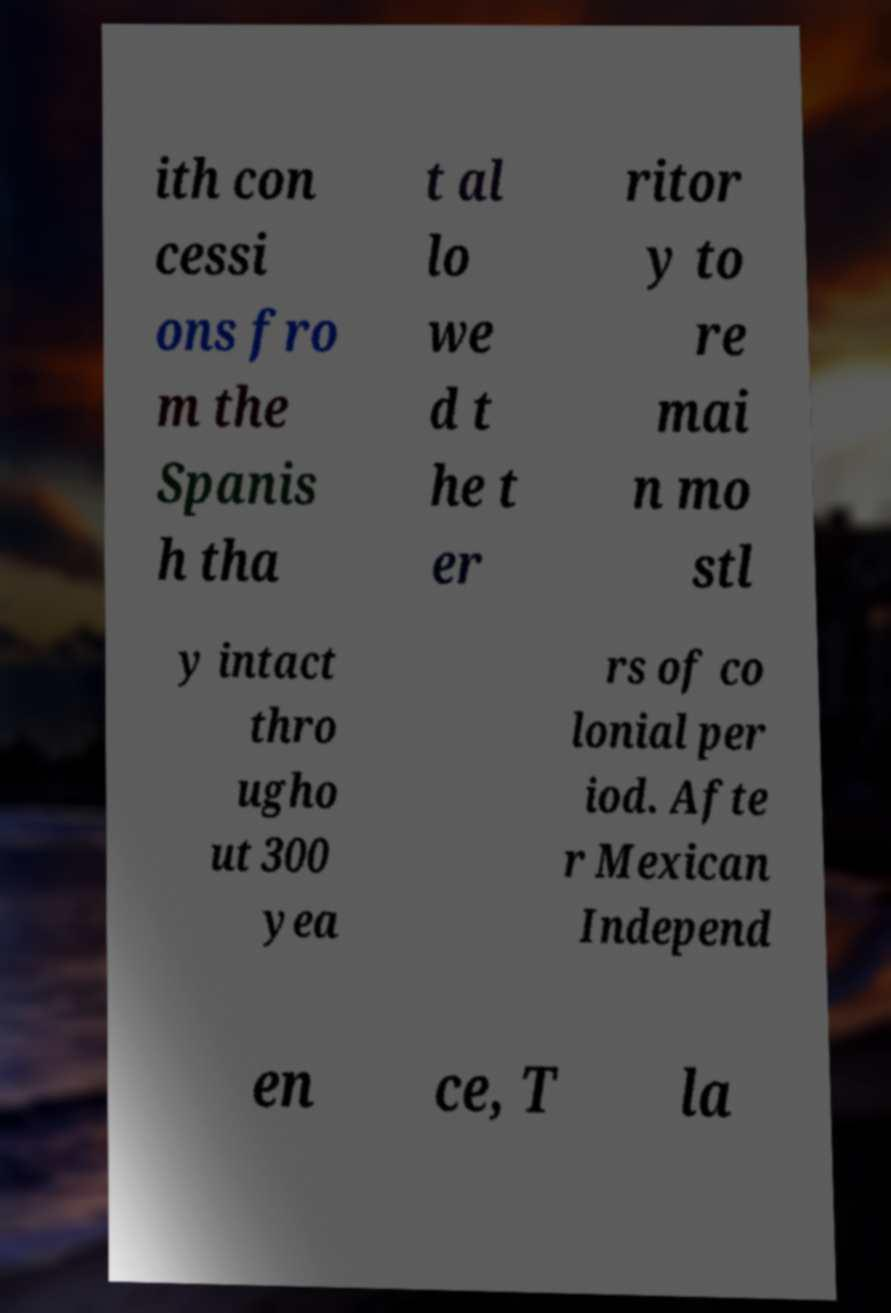I need the written content from this picture converted into text. Can you do that? ith con cessi ons fro m the Spanis h tha t al lo we d t he t er ritor y to re mai n mo stl y intact thro ugho ut 300 yea rs of co lonial per iod. Afte r Mexican Independ en ce, T la 